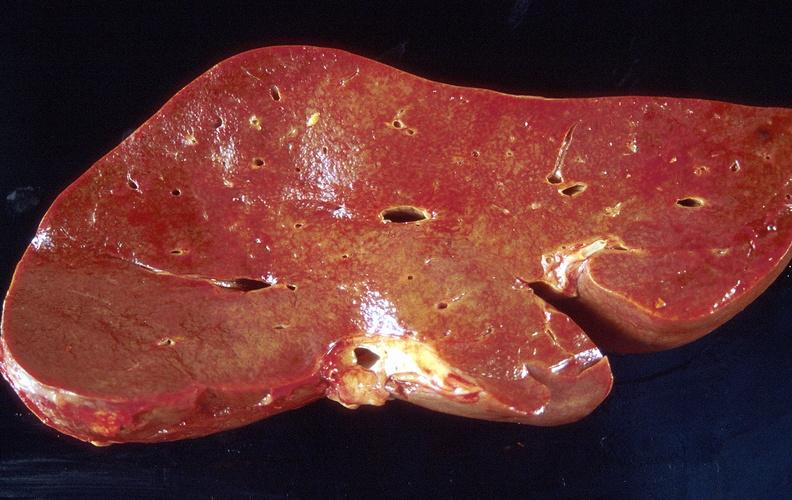does this image show amyloid, liver, spleen, and kidney?
Answer the question using a single word or phrase. Yes 